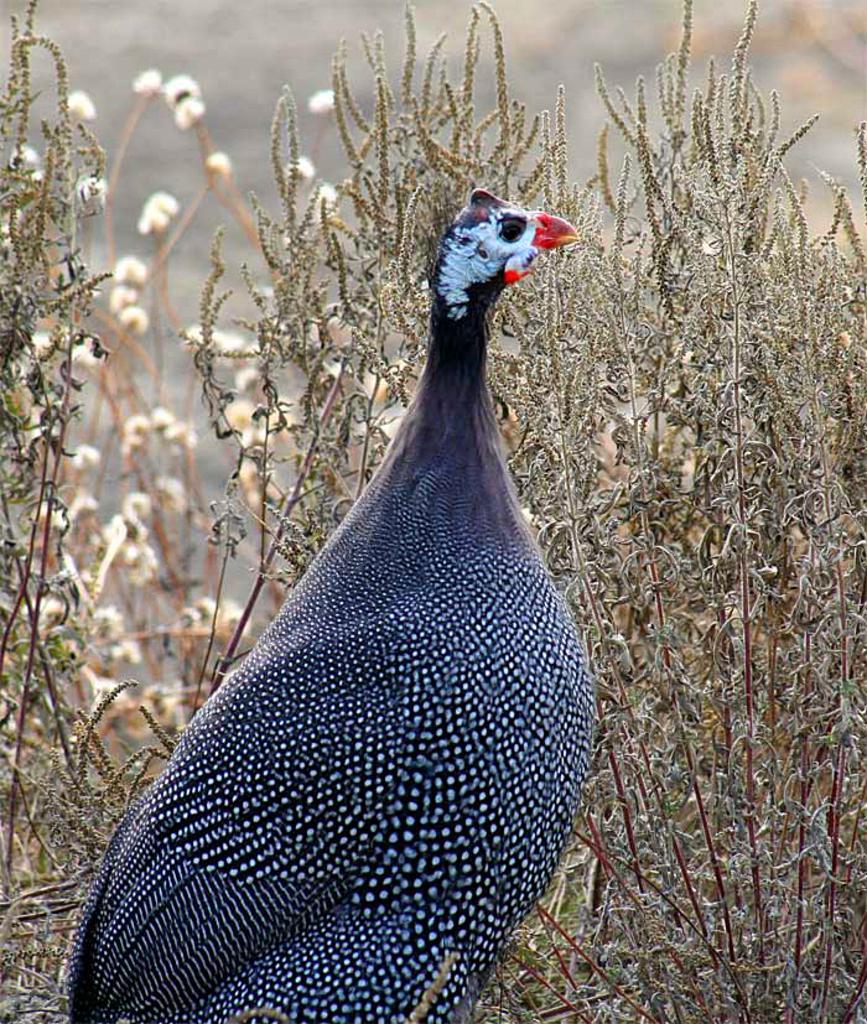Can you describe this image briefly? In this picture, there is a bird which is black and white in color. Behind it, there are plants. 